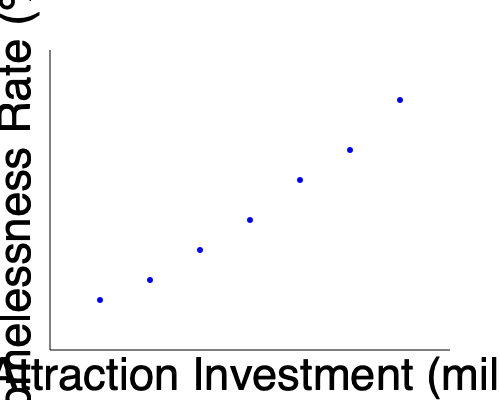Based on the scatter plot showing the relationship between tourist attraction investment and homelessness rates in a city, what conclusion can be drawn about the impact of increased tourism development on the local housing crisis? To answer this question, we need to analyze the scatter plot:

1. Observe the overall trend: As we move from left to right (increasing tourist attraction investment), the data points generally move downwards (decreasing homelessness rate).

2. Correlation direction: This negative correlation suggests that as more money is invested in tourist attractions, the homelessness rate tends to decrease.

3. Strength of correlation: The points form a fairly consistent downward trend, indicating a moderately strong correlation.

4. Potential explanations:
   a) Tourism investment might lead to job creation, potentially reducing homelessness.
   b) Increased tourism could boost the local economy, indirectly affecting housing affordability.
   c) However, this correlation does not necessarily imply causation.

5. Critical analysis: As a community organizer advocating for social housing, it's important to consider that:
   a) The data doesn't show the full picture of housing affordability or displacement.
   b) Tourist developments might be prioritized over direct investment in affordable housing.
   c) The apparent decrease in homelessness might be due to other factors not shown in the graph.

6. Conclusion: While the data suggests a negative correlation between tourist attraction investment and homelessness rates, it's crucial to advocate for direct investment in social housing alongside tourism development to address the housing crisis comprehensively.
Answer: Negative correlation between tourist attraction investment and homelessness rates, but causation not proven; direct social housing investment still crucial. 